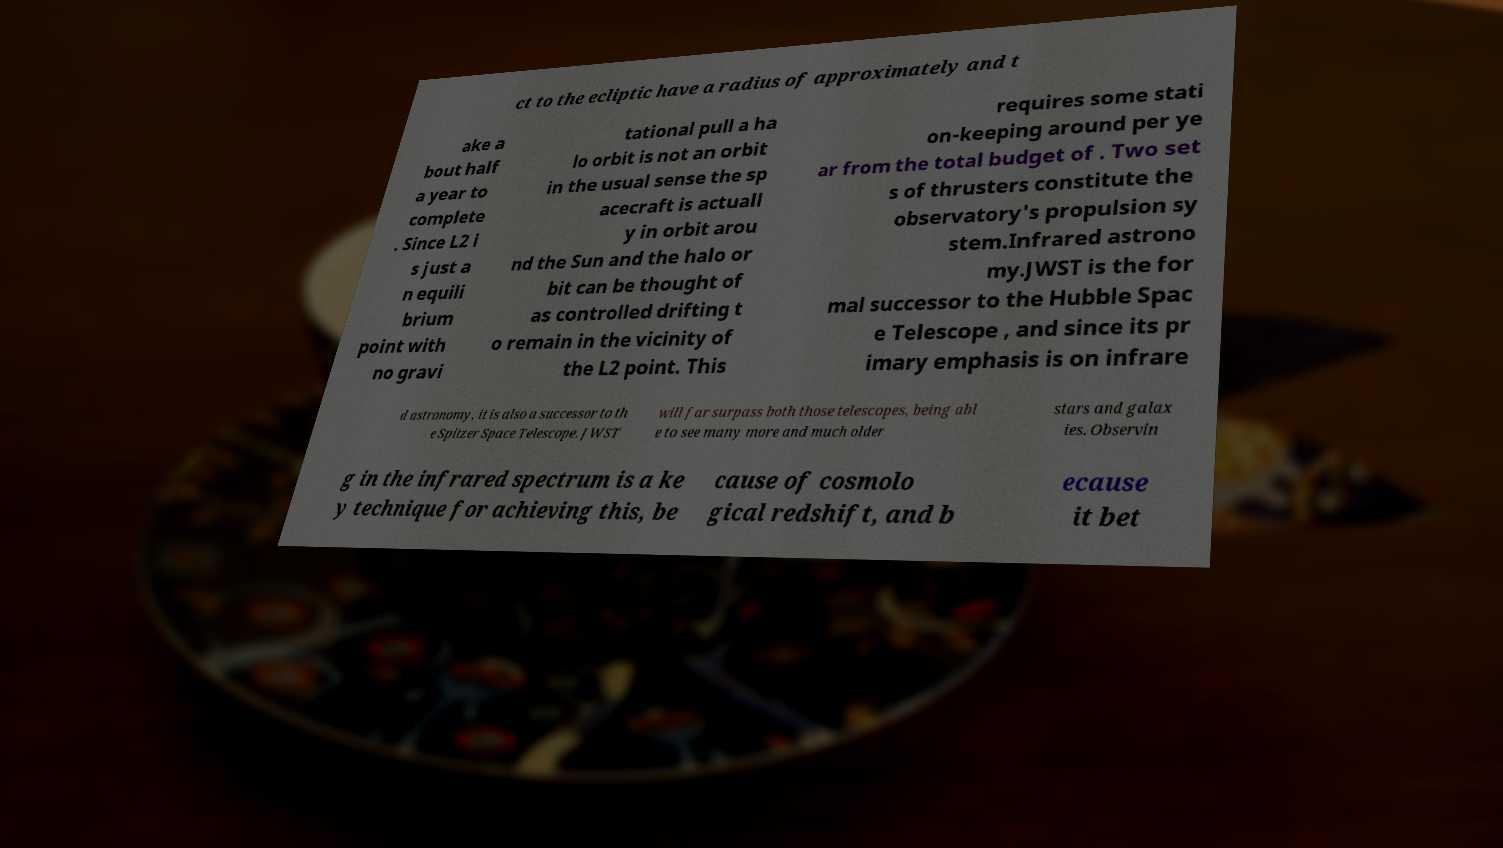Can you read and provide the text displayed in the image?This photo seems to have some interesting text. Can you extract and type it out for me? ct to the ecliptic have a radius of approximately and t ake a bout half a year to complete . Since L2 i s just a n equili brium point with no gravi tational pull a ha lo orbit is not an orbit in the usual sense the sp acecraft is actuall y in orbit arou nd the Sun and the halo or bit can be thought of as controlled drifting t o remain in the vicinity of the L2 point. This requires some stati on-keeping around per ye ar from the total budget of . Two set s of thrusters constitute the observatory's propulsion sy stem.Infrared astrono my.JWST is the for mal successor to the Hubble Spac e Telescope , and since its pr imary emphasis is on infrare d astronomy, it is also a successor to th e Spitzer Space Telescope. JWST will far surpass both those telescopes, being abl e to see many more and much older stars and galax ies. Observin g in the infrared spectrum is a ke y technique for achieving this, be cause of cosmolo gical redshift, and b ecause it bet 